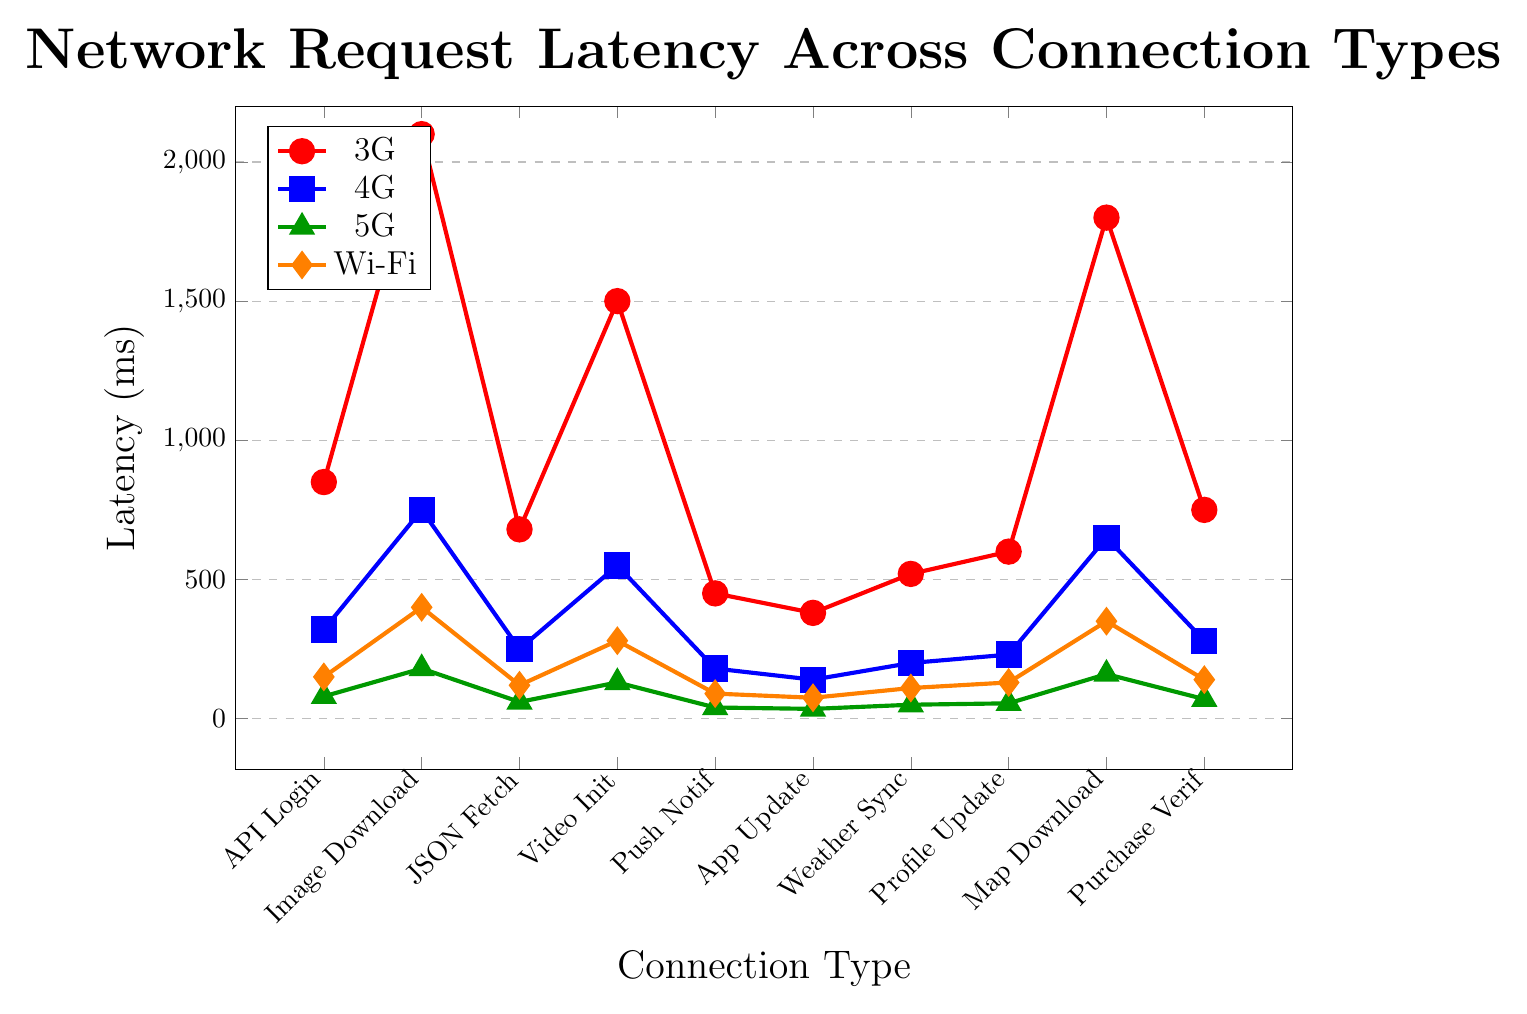What's the difference in latency between 3G and 5G for Image Download? To find the difference in latency between 3G and 5G, subtract the latency of 5G from 3G for Image Download. The values are 2100 ms (3G) and 180 ms (5G). 2100 - 180 = 1920 ms.
Answer: 1920 ms Which connection type has the lowest latency for Video Stream Initialization? Compare the latencies for Video Stream Initialization for all connection types. The values are: 3G: 1500 ms, 4G: 550 ms, 5G: 130 ms, Wi-Fi: 280 ms. The lowest value is 130 ms for 5G.
Answer: 5G What is the average latency across all connection types for Push Notification? To find the average latency for Push Notification, add the latencies for each connection type and divide by the number of types (four). The values are 450 ms (3G), 180 ms (4G), 40 ms (5G), and 90 ms (Wi-Fi). (450 + 180 + 40 + 90) / 4 = 760 / 4 = 190 ms.
Answer: 190 ms Which network request has the highest latency on a 4G connection? Look at the latencies for all network requests under the 4G connection. The values are: API Login: 320 ms, Image Download: 750 ms, JSON Data Fetch: 250 ms, Video Stream Initialization: 550 ms, Push Notification: 180 ms, App Update Check: 140 ms, Weather Data Sync: 200 ms, User Profile Update: 230 ms, Map Tile Download: 650 ms, In-App Purchase Verification: 280 ms. The highest value is 750 ms for Image Download.
Answer: Image Download Is the latency for App Update Check higher or lower on Wi-Fi compared to 4G? Compare the latency values for App Update Check on Wi-Fi and 4G. Wi-Fi: 75 ms, 4G: 140 ms. Since 75 ms is less than 140 ms, it's lower on Wi-Fi.
Answer: Lower What's the overall trend in latencies when moving from 3G to 5G for most requests? Compare the latencies from 3G to 5G across various requests. In most cases, the latency decreases significantly from 3G to 5G (e.g., API Login: 850 ms to 80 ms, Image Download: 2100 ms to 180 ms).
Answer: Decreasing How much time can be saved on average when switching from 3G to Wi-Fi for Weather Data Sync? To find the time saved, calculate the difference in latency between 3G and Wi-Fi for Weather Data Sync, which are 520 ms and 110 ms, respectively. 520 - 110 = 410 ms.
Answer: 410 ms What is the median latency value for the 4G connection type across all requests? First, list the 4G latencies: 320, 750, 250, 550, 180, 140, 200, 230, 650, 280. Sort them: 140, 180, 200, 230, 250, 280, 320, 550, 650, 750. The median is the average of the 5th and 6th values: (250 + 280) / 2 = 265 ms.
Answer: 265 ms 